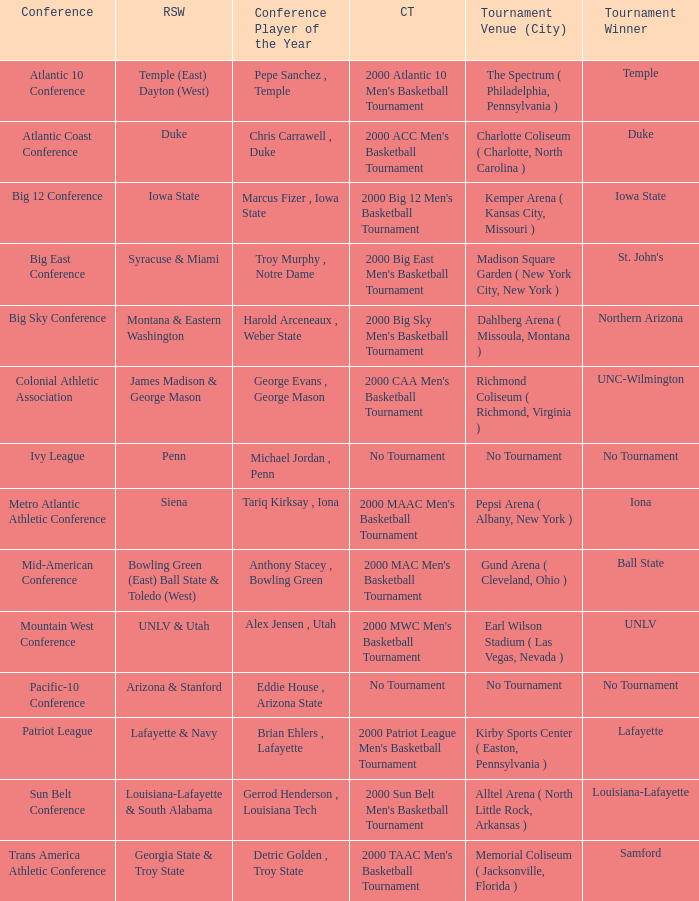How many players of the year are there in the Mountain West Conference? 1.0. 